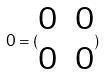Convert formula to latex. <formula><loc_0><loc_0><loc_500><loc_500>0 = ( \begin{matrix} 0 & 0 \\ 0 & 0 \end{matrix} )</formula> 